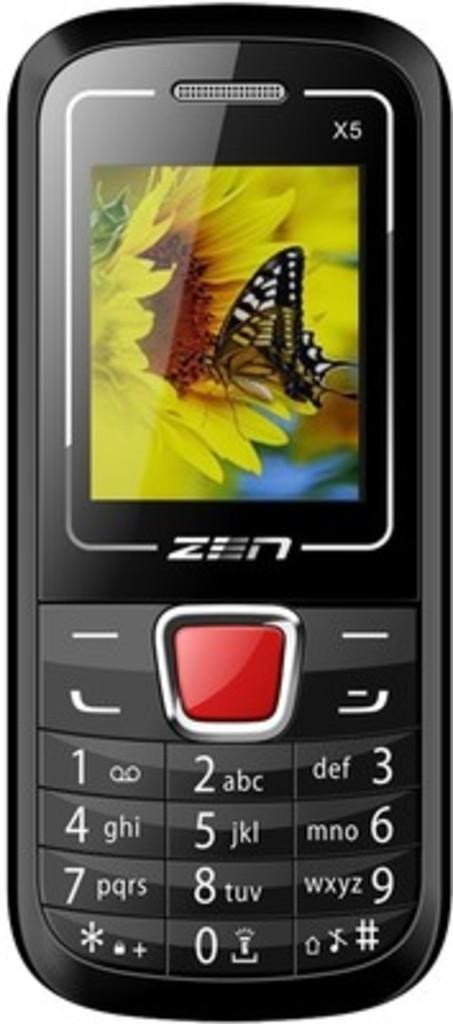What phone brand is this?
Offer a terse response. Zen. What brand phone is this?
Your answer should be compact. Zen. 